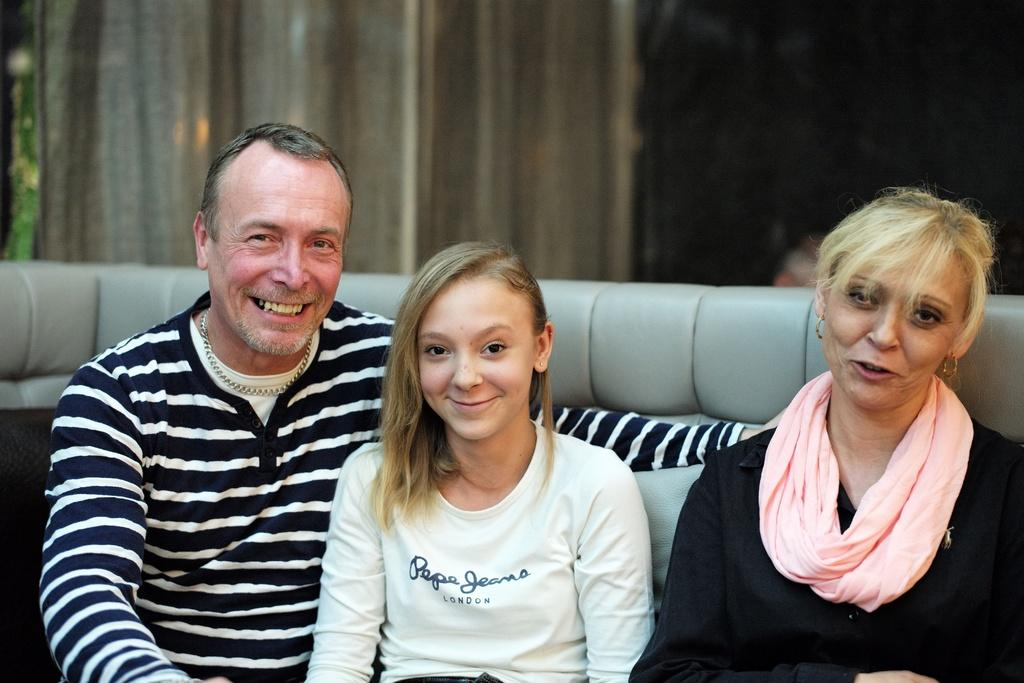What are the people in the image doing? There are people seated on a sofa in the image. What can be seen in the background of the image? There appear to be people seated in the background of the image. What is the mood of the people in the image? The people have smiles on their faces, indicating a positive mood. What is present on the windows in the image? There are curtains visible in the image. What type of error can be seen on the page in the image? There is no page or error present in the image. 